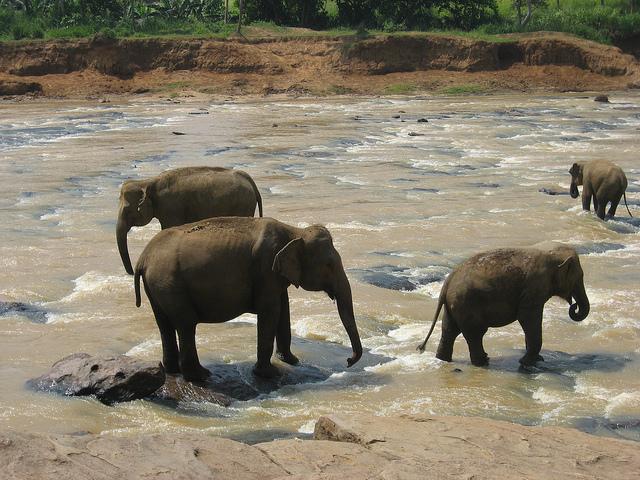Is this an elephant family?
Write a very short answer. Yes. Are the elephants adults or children?
Quick response, please. Children. Does distance affect the apparent size of the elephants?
Write a very short answer. Yes. 